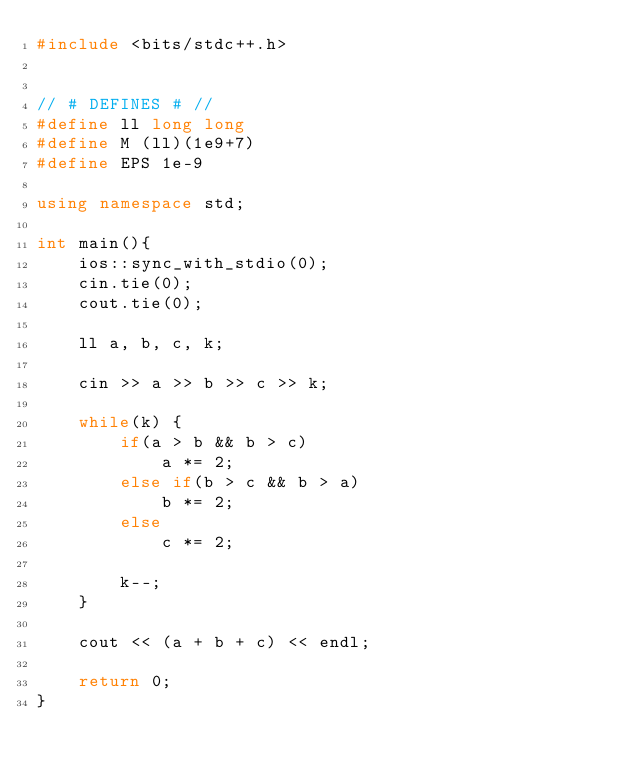<code> <loc_0><loc_0><loc_500><loc_500><_C++_>#include <bits/stdc++.h>


// # DEFINES # //
#define ll long long
#define M (ll)(1e9+7)
#define EPS 1e-9

using namespace std;

int main(){
    ios::sync_with_stdio(0);
    cin.tie(0);
    cout.tie(0);

    ll a, b, c, k;

    cin >> a >> b >> c >> k;

    while(k) {
        if(a > b && b > c)
            a *= 2;
        else if(b > c && b > a)
            b *= 2;
        else 
            c *= 2;

        k--;
    }

    cout << (a + b + c) << endl;

    return 0;
}</code> 